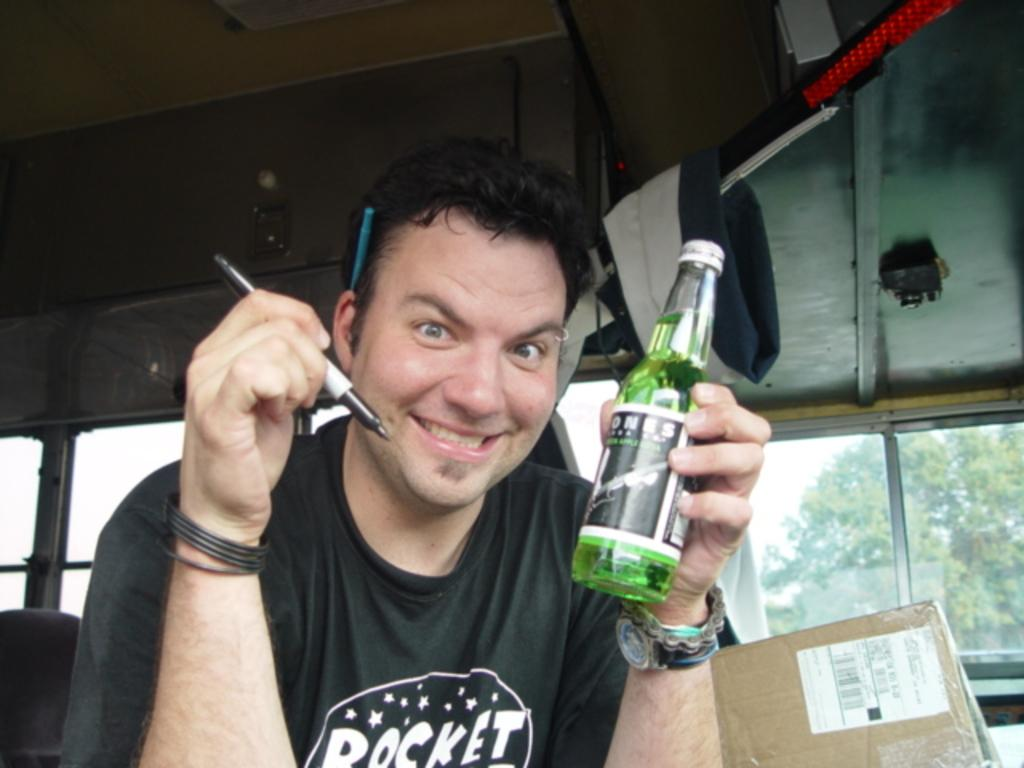Who is present in the image? There is a man in the picture. What is the man doing in the image? The man is sitting. What objects is the man holding in the image? The man is holding a bottle in his left hand and a pen in his right hand. What is the man's facial expression in the image? The man is smiling. What type of oven can be seen in the background of the image? There is no oven present in the image. How many quinces are visible on the table in the image? There are no quinces present in the image. 